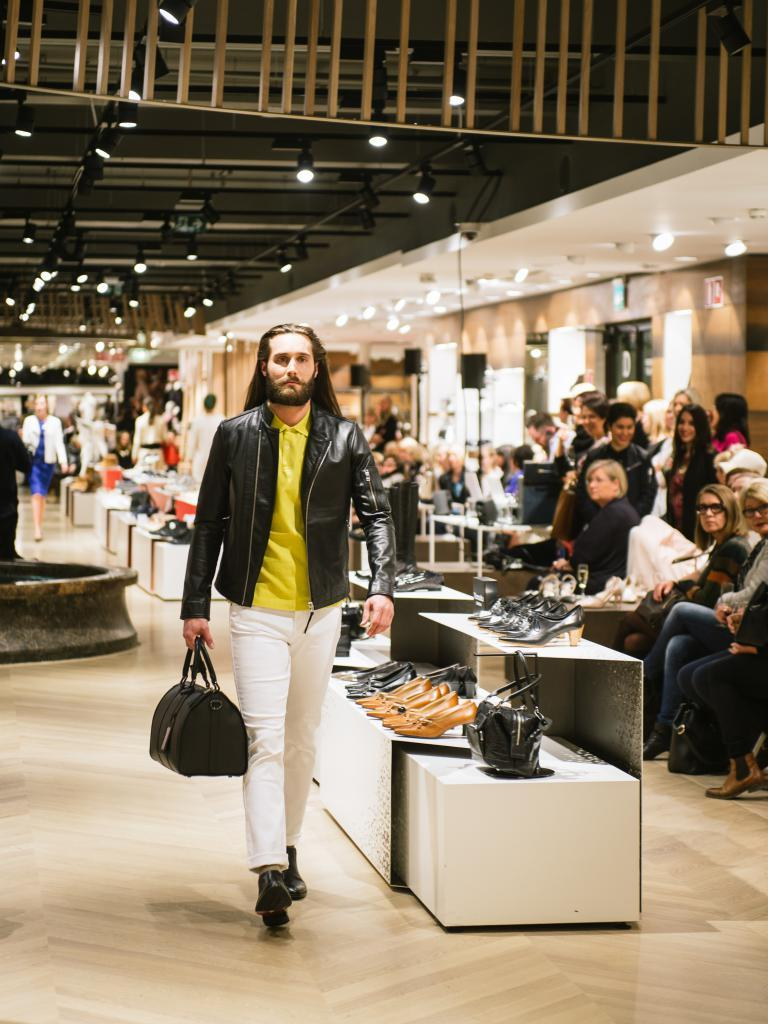What is the man in the image doing? The man is holding a bag and is on the floor. Can you describe the man's surroundings? There are people and lights in the background of the image, as well as tables with objects on them. What might the man be doing with the bag? It is unclear what the man is doing with the bag, but he is holding it. What type of rose is the man holding in the image? There is no rose present in the image; the man is holding a bag. Can you tell me how many horses are visible in the image? There are no horses present in the image. 